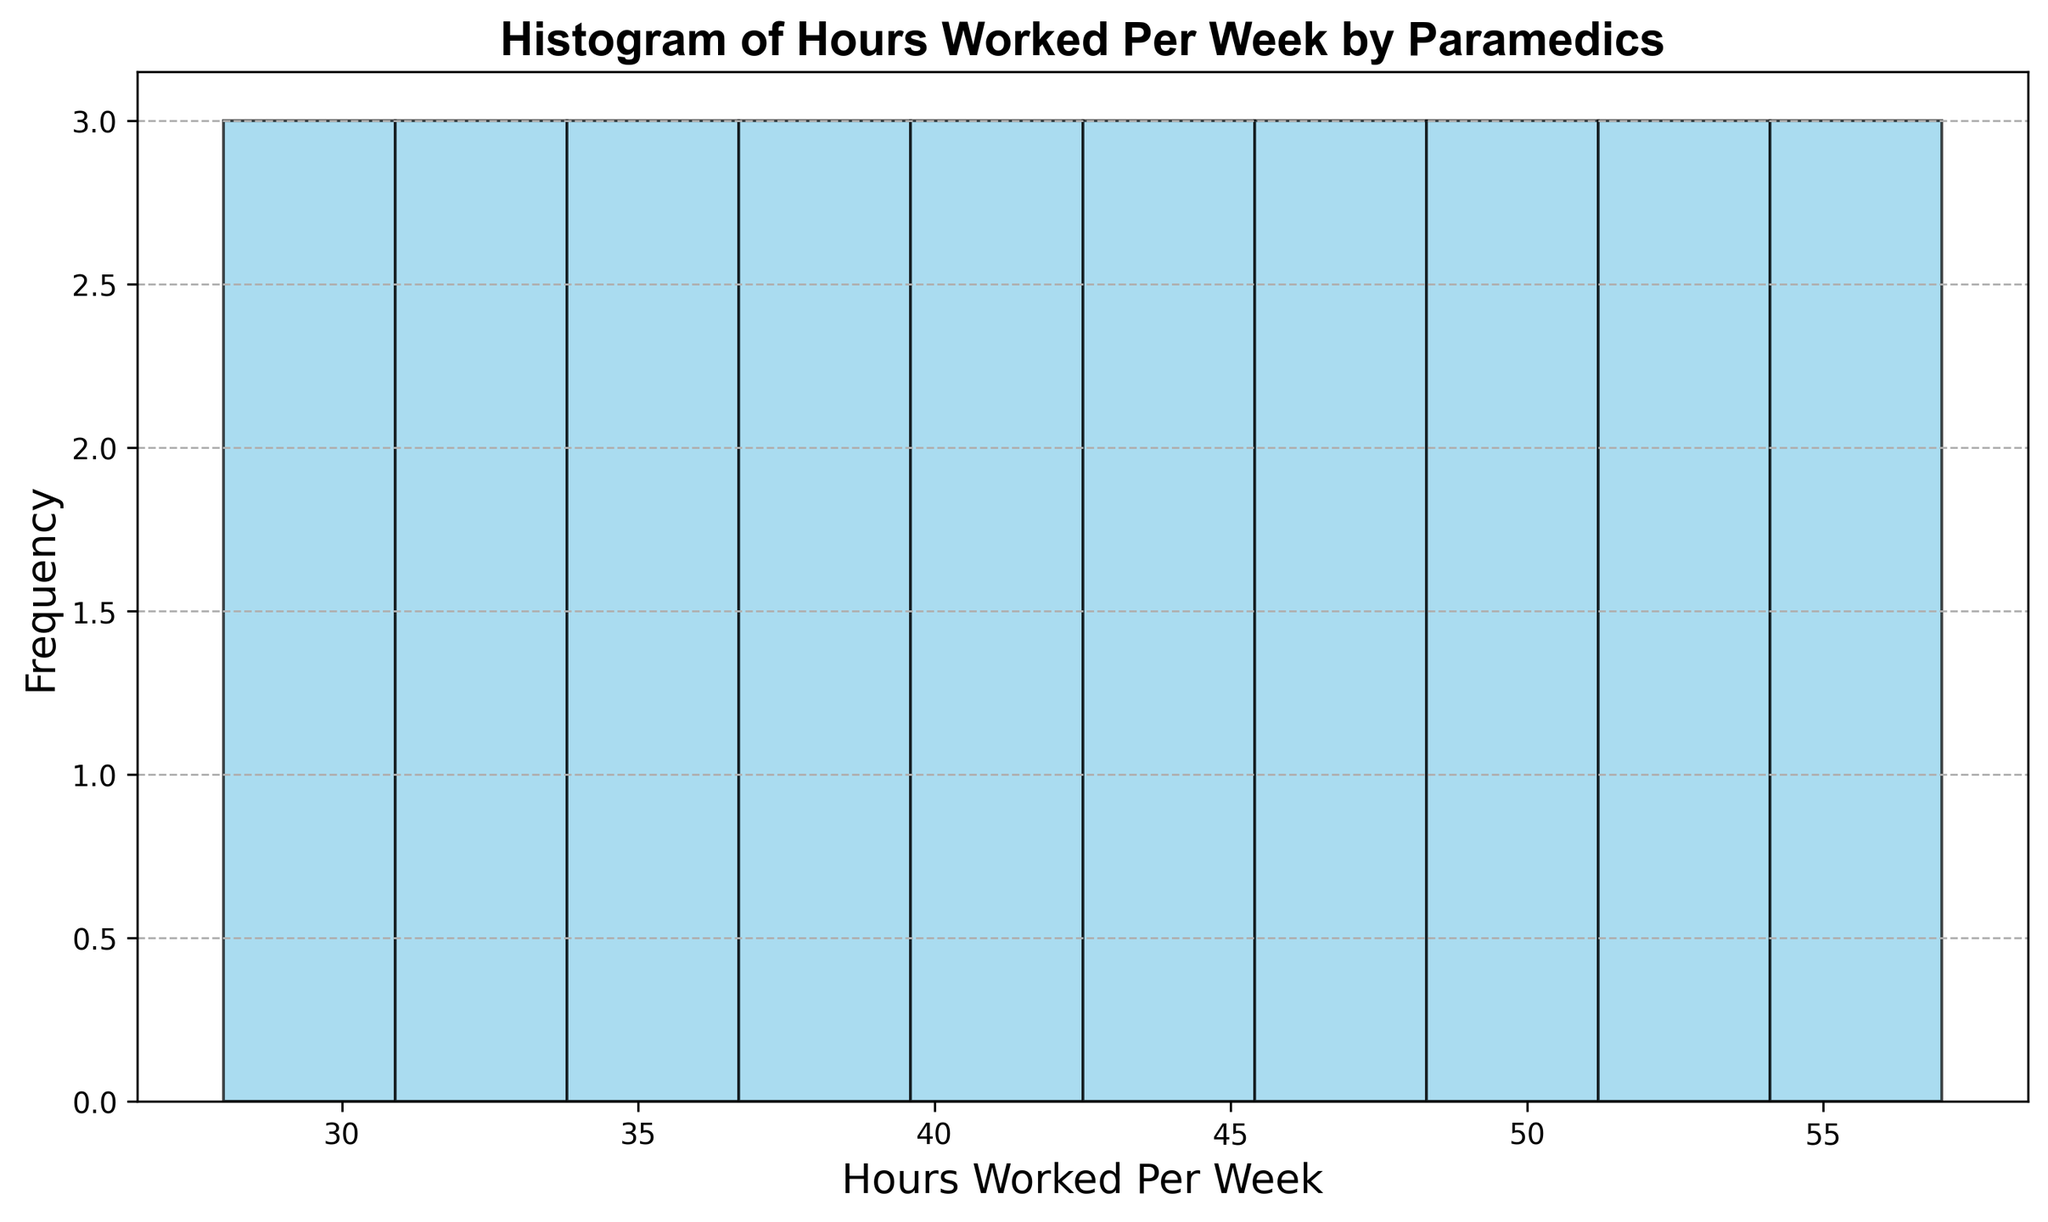How many paramedics work fewer than 35 hours per week? To find the number of paramedics working fewer than 35 hours per week, we look at the histogram and count the bars that represent hours less than 35. Each bar represents the frequency of paramedics within that range.
Answer: 2 What is the most common range of hours worked per week by paramedics? The most common range of hours is represented by the tallest bar in the histogram. This indicates the range with the highest frequency.
Answer: 40-44 hours How many paramedics work between 45 and 49 hours per week? Identify the bar on the histogram that covers the 45-49 hour range and read the frequency from the y-axis. This tells us how many paramedics fall into that category.
Answer: 5 Compare the number of paramedics working between 35-39 hours and those working between 50-54 hours per week. Which category has more paramedics? First, find the bar representing 35-39 hours and note its frequency, then do the same for the 50-54 hour range. Compare the two frequencies.
Answer: 35-39 hours What is the total number of paramedics working 55 hours or more per week? Identify the bars that cover the 55+ hour ranges and sum their frequencies.
Answer: 2 Which range has the least number of paramedics, and what is that number? Find the shortest bar on the histogram and read its frequency to identify the range and number of paramedics.
Answer: 55-59 hours, 1 If you were to average the number of paramedics working in each range of 5 hours, what would that average be? Sum all the frequencies for each 5-hour range and divide by the number of ranges. This calculation gives the average frequency per range.
Answer: (1+1+2+4+4+7+5+3+2+2)/10 = 3.1 How does the number of paramedics working 40-44 hours compare to those working 45-49 hours per week? Look at the histogram bars for 40-44 hours and 45-49 hours. Compare their heights (frequencies) to determine which is greater.
Answer: More paramedics work 40-44 hours What is the total number of paramedics accounted for in the histogram? Add the frequencies of all bars in the histogram to get the total number of paramedics surveyed.
Answer: 31 